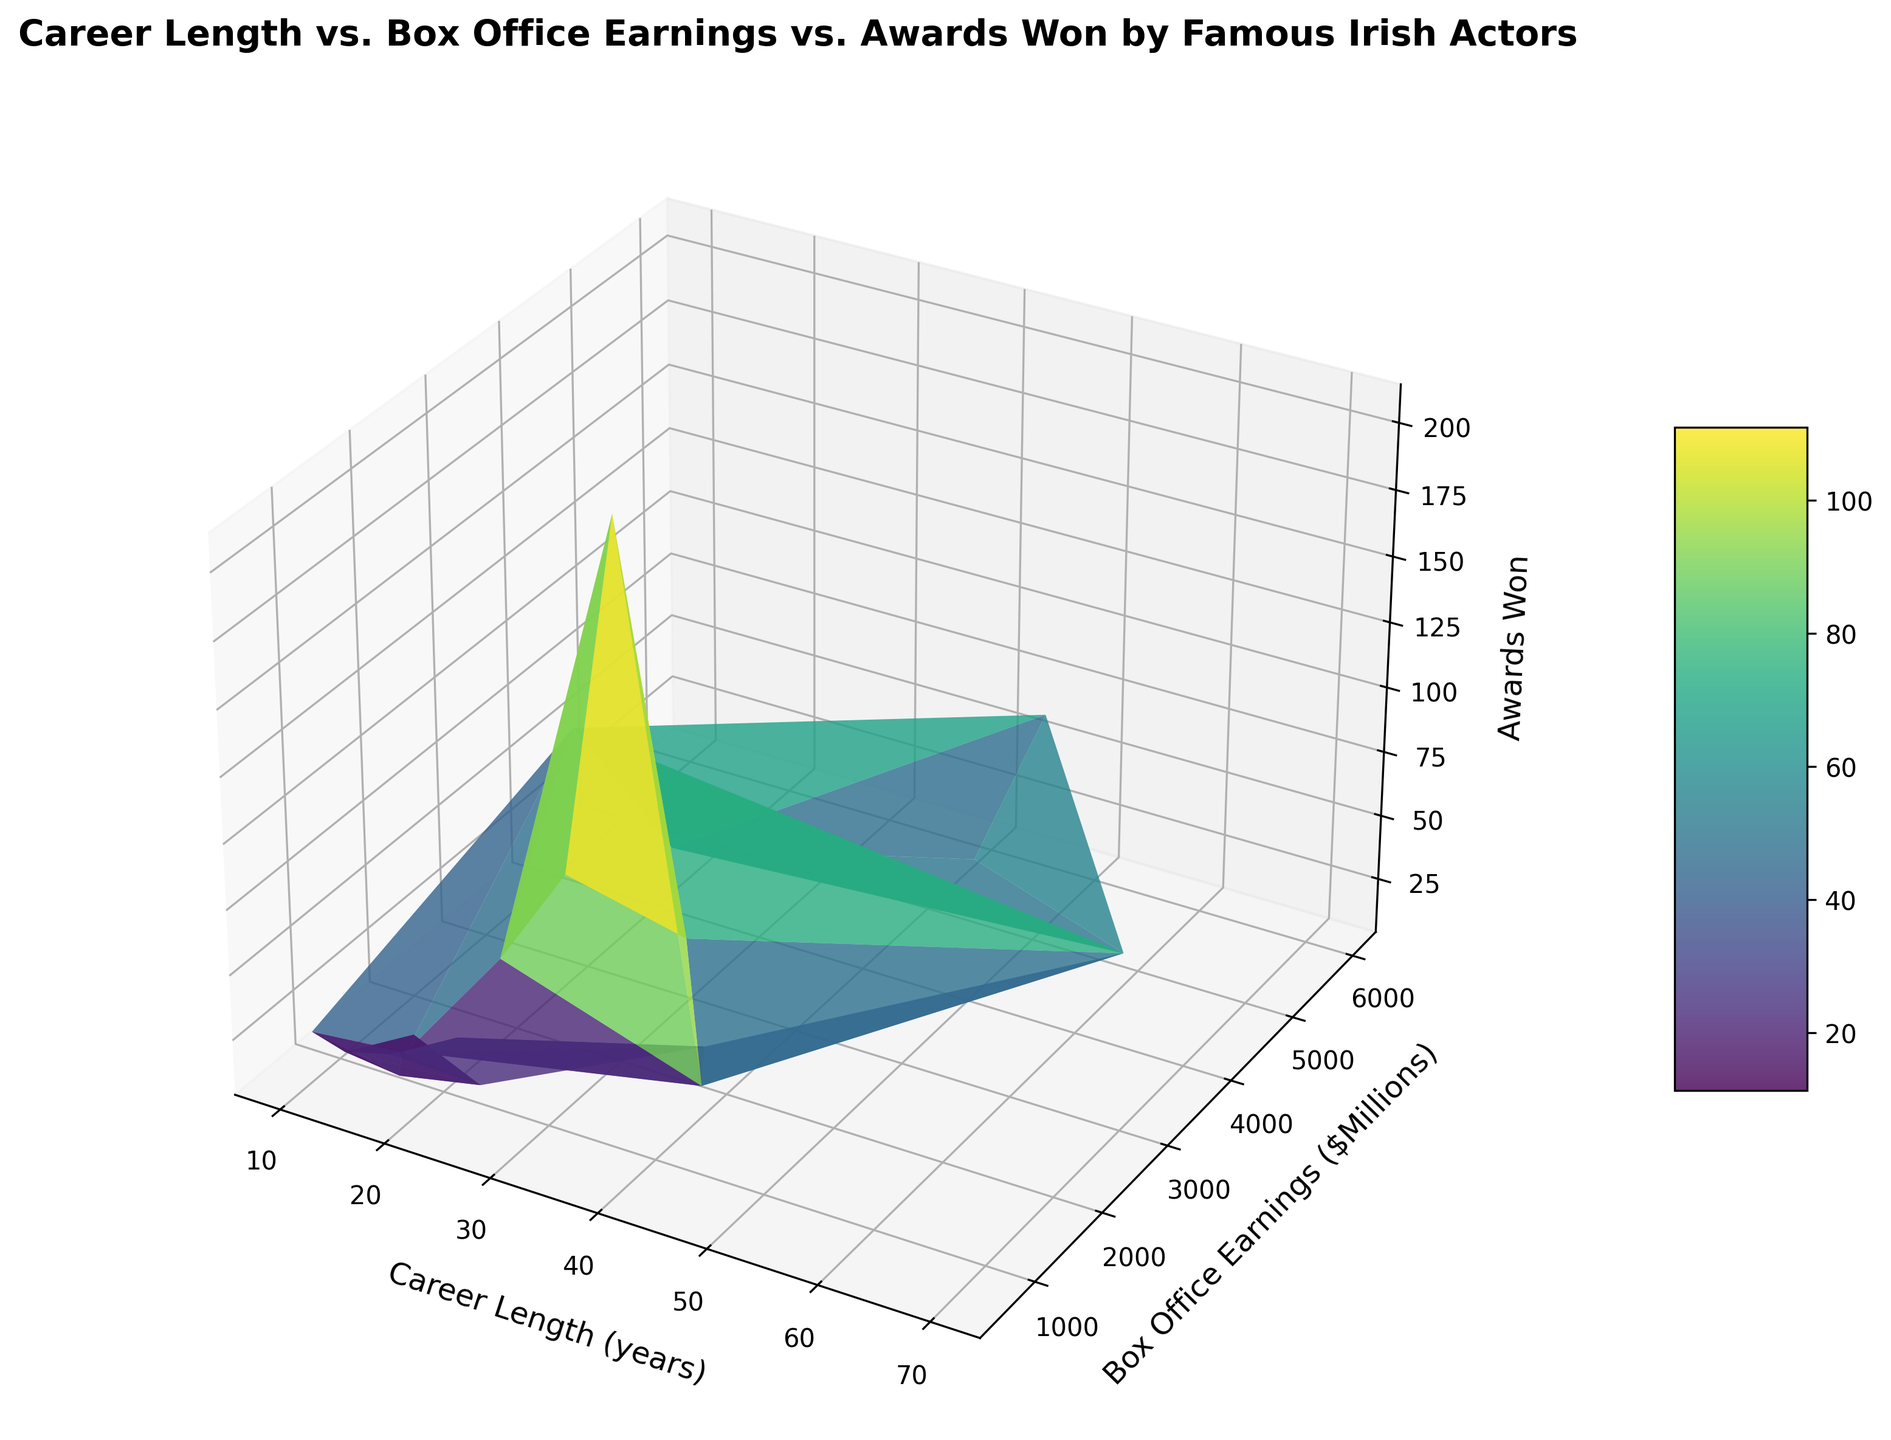What's the career length of the actor with the highest box office earnings? To determine this, we locate the actor with the highest box office earnings on the X-axis and then trace vertically to identify the corresponding career length on the Z-axis.
Answer: 45 years Which actor has won more awards: an actor with 25 years of career length and 2000 million in box office earnings, or the actor with 70 years of career length and 3000 million in box office earnings? By checking first actor with 25 years and 2000 million, we see 70 awards and for 70 years and 3000 million, we see 72 awards.
Answer: Maureen O'Hara Is there a correlation between longer career length and more awards won? By looking at the plot's overall shape and color pattern, the trend line of Career Length and Awards reveals that actors with longer careers tend to have won more awards.
Answer: Yes Which actor(s) achieved over 3000 million box office earnings but won less than 50 awards? By identifying actors above the 3000 million mark on Y-axis and then filtering by Z-axis under 50 awards, we find the result.
Answer: Colin Farrell How does the box office earnings of the actor with the shortest career length compare to the actor with the longest career length? Actors with shortest career length have 10 (Barry Keoghan) and longest have 70 (Maureen O'Hara). Compare earnings 650 vs 3000 million.
Answer: Much less for the shortest Identify any outliers in terms of awards won for a given career length. Checking the plot, Daniel Day-Lewis is a standout with 210 awards in 30-year career, significantly more than his peers.
Answer: Daniel Day-Lewis What's the average box office earnings of actors with more than 40 years of career length? Identifying actors with more than 40-year careers: Liam Neeson, Pierce Brosnan, and Kenneth Branagh. Sum their earnings (6000 + 4900 + 1500) equals 12400 and average is 12400/3 = 4133.33
Answer: 4133.33 million Which group has the higher number of awards, actors with career lengths between 10-20 years, or those with 40-50 years? Summing awards: 19+18+15+23+14+28=117 in 10-20 group, and 64+32+21=117 in 40-50. Both groups have equal awards.
Answer: Equal amounts, 117 How does the trend of awards won differ among actors with similar box office earnings but different career lengths? Examining the trend via Z-axis for similar Y-axis values, actors with longer careers frequently show higher Z-values for same Y-values.
Answer: Longer careers have more awards Do actors with higher box office earnings consistently win the most awards? Checking the pattern of Z-values against Y-values, actors like Daniel Day-Lewis have high awards but aren't the highest earners, indicating no consistent trend.
Answer: No 